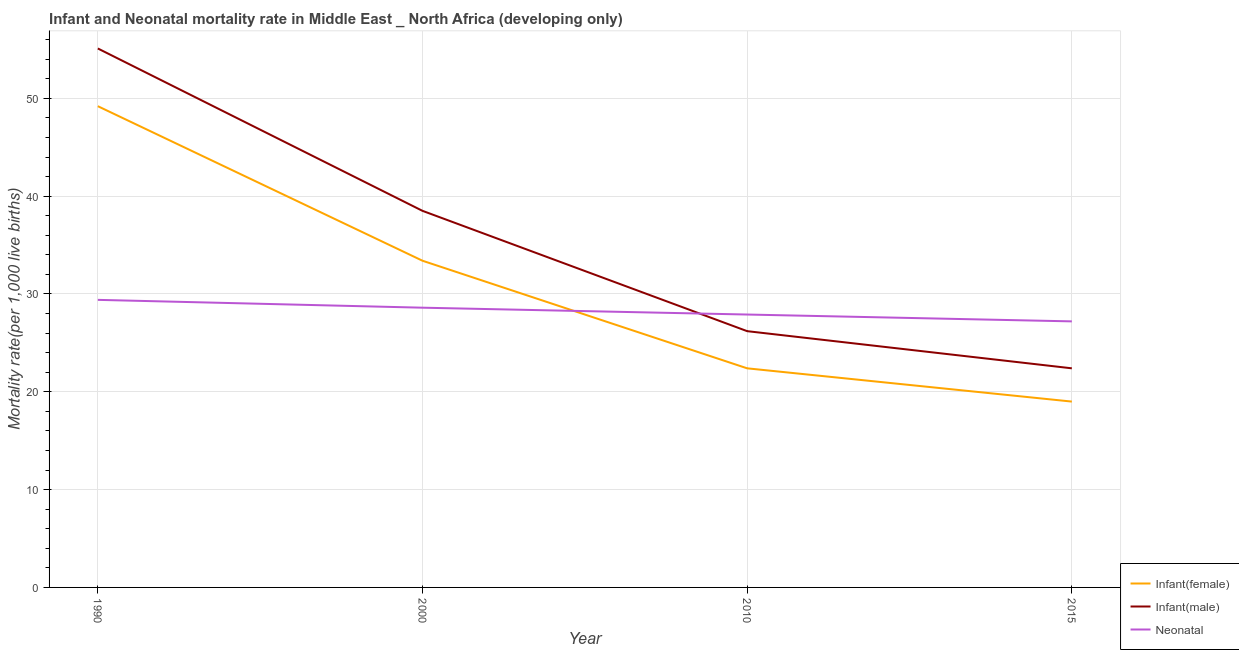Does the line corresponding to neonatal mortality rate intersect with the line corresponding to infant mortality rate(female)?
Give a very brief answer. Yes. What is the infant mortality rate(female) in 1990?
Offer a very short reply. 49.2. Across all years, what is the maximum infant mortality rate(female)?
Give a very brief answer. 49.2. Across all years, what is the minimum infant mortality rate(male)?
Your answer should be very brief. 22.4. In which year was the infant mortality rate(female) minimum?
Your answer should be compact. 2015. What is the total neonatal mortality rate in the graph?
Provide a succinct answer. 113.1. What is the difference between the neonatal mortality rate in 2010 and that in 2015?
Ensure brevity in your answer.  0.7. What is the difference between the infant mortality rate(female) in 2015 and the neonatal mortality rate in 2000?
Make the answer very short. -9.6. What is the average infant mortality rate(female) per year?
Offer a very short reply. 31. In the year 2010, what is the difference between the infant mortality rate(male) and infant mortality rate(female)?
Keep it short and to the point. 3.8. In how many years, is the infant mortality rate(male) greater than 38?
Provide a succinct answer. 2. What is the ratio of the infant mortality rate(female) in 1990 to that in 2010?
Offer a terse response. 2.2. Is the infant mortality rate(female) in 2000 less than that in 2015?
Your response must be concise. No. Is the difference between the infant mortality rate(male) in 2000 and 2015 greater than the difference between the neonatal mortality rate in 2000 and 2015?
Keep it short and to the point. Yes. What is the difference between the highest and the second highest neonatal mortality rate?
Your answer should be very brief. 0.8. What is the difference between the highest and the lowest infant mortality rate(male)?
Offer a terse response. 32.7. Is the sum of the infant mortality rate(female) in 1990 and 2015 greater than the maximum neonatal mortality rate across all years?
Your answer should be very brief. Yes. Is the infant mortality rate(female) strictly greater than the neonatal mortality rate over the years?
Your answer should be very brief. No. Is the infant mortality rate(male) strictly less than the neonatal mortality rate over the years?
Offer a terse response. No. How many years are there in the graph?
Give a very brief answer. 4. Are the values on the major ticks of Y-axis written in scientific E-notation?
Ensure brevity in your answer.  No. Does the graph contain any zero values?
Offer a very short reply. No. Does the graph contain grids?
Your response must be concise. Yes. How many legend labels are there?
Keep it short and to the point. 3. How are the legend labels stacked?
Keep it short and to the point. Vertical. What is the title of the graph?
Offer a terse response. Infant and Neonatal mortality rate in Middle East _ North Africa (developing only). What is the label or title of the Y-axis?
Offer a very short reply. Mortality rate(per 1,0 live births). What is the Mortality rate(per 1,000 live births) of Infant(female) in 1990?
Offer a terse response. 49.2. What is the Mortality rate(per 1,000 live births) in Infant(male) in 1990?
Give a very brief answer. 55.1. What is the Mortality rate(per 1,000 live births) of Neonatal  in 1990?
Provide a succinct answer. 29.4. What is the Mortality rate(per 1,000 live births) of Infant(female) in 2000?
Provide a succinct answer. 33.4. What is the Mortality rate(per 1,000 live births) of Infant(male) in 2000?
Your answer should be very brief. 38.5. What is the Mortality rate(per 1,000 live births) of Neonatal  in 2000?
Your answer should be very brief. 28.6. What is the Mortality rate(per 1,000 live births) of Infant(female) in 2010?
Provide a succinct answer. 22.4. What is the Mortality rate(per 1,000 live births) of Infant(male) in 2010?
Your answer should be very brief. 26.2. What is the Mortality rate(per 1,000 live births) in Neonatal  in 2010?
Keep it short and to the point. 27.9. What is the Mortality rate(per 1,000 live births) in Infant(male) in 2015?
Your answer should be very brief. 22.4. What is the Mortality rate(per 1,000 live births) of Neonatal  in 2015?
Provide a succinct answer. 27.2. Across all years, what is the maximum Mortality rate(per 1,000 live births) of Infant(female)?
Provide a short and direct response. 49.2. Across all years, what is the maximum Mortality rate(per 1,000 live births) of Infant(male)?
Your answer should be very brief. 55.1. Across all years, what is the maximum Mortality rate(per 1,000 live births) in Neonatal ?
Your answer should be compact. 29.4. Across all years, what is the minimum Mortality rate(per 1,000 live births) in Infant(female)?
Provide a short and direct response. 19. Across all years, what is the minimum Mortality rate(per 1,000 live births) of Infant(male)?
Ensure brevity in your answer.  22.4. Across all years, what is the minimum Mortality rate(per 1,000 live births) of Neonatal ?
Provide a short and direct response. 27.2. What is the total Mortality rate(per 1,000 live births) of Infant(female) in the graph?
Offer a terse response. 124. What is the total Mortality rate(per 1,000 live births) in Infant(male) in the graph?
Keep it short and to the point. 142.2. What is the total Mortality rate(per 1,000 live births) in Neonatal  in the graph?
Keep it short and to the point. 113.1. What is the difference between the Mortality rate(per 1,000 live births) in Infant(female) in 1990 and that in 2000?
Give a very brief answer. 15.8. What is the difference between the Mortality rate(per 1,000 live births) of Infant(female) in 1990 and that in 2010?
Give a very brief answer. 26.8. What is the difference between the Mortality rate(per 1,000 live births) in Infant(male) in 1990 and that in 2010?
Provide a short and direct response. 28.9. What is the difference between the Mortality rate(per 1,000 live births) in Neonatal  in 1990 and that in 2010?
Ensure brevity in your answer.  1.5. What is the difference between the Mortality rate(per 1,000 live births) in Infant(female) in 1990 and that in 2015?
Your answer should be compact. 30.2. What is the difference between the Mortality rate(per 1,000 live births) of Infant(male) in 1990 and that in 2015?
Offer a very short reply. 32.7. What is the difference between the Mortality rate(per 1,000 live births) of Infant(female) in 2000 and that in 2010?
Offer a very short reply. 11. What is the difference between the Mortality rate(per 1,000 live births) in Infant(male) in 2000 and that in 2010?
Provide a short and direct response. 12.3. What is the difference between the Mortality rate(per 1,000 live births) of Neonatal  in 2000 and that in 2010?
Offer a terse response. 0.7. What is the difference between the Mortality rate(per 1,000 live births) in Infant(female) in 2000 and that in 2015?
Provide a succinct answer. 14.4. What is the difference between the Mortality rate(per 1,000 live births) in Infant(female) in 2010 and that in 2015?
Provide a succinct answer. 3.4. What is the difference between the Mortality rate(per 1,000 live births) in Infant(male) in 2010 and that in 2015?
Make the answer very short. 3.8. What is the difference between the Mortality rate(per 1,000 live births) in Infant(female) in 1990 and the Mortality rate(per 1,000 live births) in Infant(male) in 2000?
Your answer should be compact. 10.7. What is the difference between the Mortality rate(per 1,000 live births) in Infant(female) in 1990 and the Mortality rate(per 1,000 live births) in Neonatal  in 2000?
Your answer should be compact. 20.6. What is the difference between the Mortality rate(per 1,000 live births) in Infant(female) in 1990 and the Mortality rate(per 1,000 live births) in Infant(male) in 2010?
Provide a succinct answer. 23. What is the difference between the Mortality rate(per 1,000 live births) of Infant(female) in 1990 and the Mortality rate(per 1,000 live births) of Neonatal  in 2010?
Give a very brief answer. 21.3. What is the difference between the Mortality rate(per 1,000 live births) of Infant(male) in 1990 and the Mortality rate(per 1,000 live births) of Neonatal  in 2010?
Keep it short and to the point. 27.2. What is the difference between the Mortality rate(per 1,000 live births) in Infant(female) in 1990 and the Mortality rate(per 1,000 live births) in Infant(male) in 2015?
Offer a terse response. 26.8. What is the difference between the Mortality rate(per 1,000 live births) of Infant(male) in 1990 and the Mortality rate(per 1,000 live births) of Neonatal  in 2015?
Give a very brief answer. 27.9. What is the difference between the Mortality rate(per 1,000 live births) of Infant(female) in 2000 and the Mortality rate(per 1,000 live births) of Infant(male) in 2015?
Your answer should be very brief. 11. What is the difference between the Mortality rate(per 1,000 live births) of Infant(female) in 2000 and the Mortality rate(per 1,000 live births) of Neonatal  in 2015?
Your answer should be compact. 6.2. What is the difference between the Mortality rate(per 1,000 live births) of Infant(female) in 2010 and the Mortality rate(per 1,000 live births) of Neonatal  in 2015?
Provide a succinct answer. -4.8. What is the average Mortality rate(per 1,000 live births) in Infant(female) per year?
Your answer should be compact. 31. What is the average Mortality rate(per 1,000 live births) in Infant(male) per year?
Give a very brief answer. 35.55. What is the average Mortality rate(per 1,000 live births) in Neonatal  per year?
Keep it short and to the point. 28.27. In the year 1990, what is the difference between the Mortality rate(per 1,000 live births) in Infant(female) and Mortality rate(per 1,000 live births) in Infant(male)?
Your answer should be very brief. -5.9. In the year 1990, what is the difference between the Mortality rate(per 1,000 live births) in Infant(female) and Mortality rate(per 1,000 live births) in Neonatal ?
Your response must be concise. 19.8. In the year 1990, what is the difference between the Mortality rate(per 1,000 live births) of Infant(male) and Mortality rate(per 1,000 live births) of Neonatal ?
Your answer should be very brief. 25.7. In the year 2000, what is the difference between the Mortality rate(per 1,000 live births) in Infant(female) and Mortality rate(per 1,000 live births) in Neonatal ?
Provide a short and direct response. 4.8. In the year 2010, what is the difference between the Mortality rate(per 1,000 live births) in Infant(female) and Mortality rate(per 1,000 live births) in Infant(male)?
Provide a succinct answer. -3.8. In the year 2010, what is the difference between the Mortality rate(per 1,000 live births) of Infant(male) and Mortality rate(per 1,000 live births) of Neonatal ?
Your response must be concise. -1.7. In the year 2015, what is the difference between the Mortality rate(per 1,000 live births) in Infant(female) and Mortality rate(per 1,000 live births) in Infant(male)?
Give a very brief answer. -3.4. In the year 2015, what is the difference between the Mortality rate(per 1,000 live births) in Infant(female) and Mortality rate(per 1,000 live births) in Neonatal ?
Your answer should be compact. -8.2. In the year 2015, what is the difference between the Mortality rate(per 1,000 live births) of Infant(male) and Mortality rate(per 1,000 live births) of Neonatal ?
Provide a succinct answer. -4.8. What is the ratio of the Mortality rate(per 1,000 live births) of Infant(female) in 1990 to that in 2000?
Give a very brief answer. 1.47. What is the ratio of the Mortality rate(per 1,000 live births) in Infant(male) in 1990 to that in 2000?
Your answer should be very brief. 1.43. What is the ratio of the Mortality rate(per 1,000 live births) of Neonatal  in 1990 to that in 2000?
Your answer should be compact. 1.03. What is the ratio of the Mortality rate(per 1,000 live births) of Infant(female) in 1990 to that in 2010?
Offer a terse response. 2.2. What is the ratio of the Mortality rate(per 1,000 live births) of Infant(male) in 1990 to that in 2010?
Provide a succinct answer. 2.1. What is the ratio of the Mortality rate(per 1,000 live births) in Neonatal  in 1990 to that in 2010?
Provide a succinct answer. 1.05. What is the ratio of the Mortality rate(per 1,000 live births) in Infant(female) in 1990 to that in 2015?
Provide a succinct answer. 2.59. What is the ratio of the Mortality rate(per 1,000 live births) of Infant(male) in 1990 to that in 2015?
Your answer should be very brief. 2.46. What is the ratio of the Mortality rate(per 1,000 live births) of Neonatal  in 1990 to that in 2015?
Your answer should be very brief. 1.08. What is the ratio of the Mortality rate(per 1,000 live births) of Infant(female) in 2000 to that in 2010?
Give a very brief answer. 1.49. What is the ratio of the Mortality rate(per 1,000 live births) in Infant(male) in 2000 to that in 2010?
Your answer should be compact. 1.47. What is the ratio of the Mortality rate(per 1,000 live births) in Neonatal  in 2000 to that in 2010?
Ensure brevity in your answer.  1.03. What is the ratio of the Mortality rate(per 1,000 live births) of Infant(female) in 2000 to that in 2015?
Offer a terse response. 1.76. What is the ratio of the Mortality rate(per 1,000 live births) of Infant(male) in 2000 to that in 2015?
Provide a succinct answer. 1.72. What is the ratio of the Mortality rate(per 1,000 live births) in Neonatal  in 2000 to that in 2015?
Provide a short and direct response. 1.05. What is the ratio of the Mortality rate(per 1,000 live births) in Infant(female) in 2010 to that in 2015?
Offer a terse response. 1.18. What is the ratio of the Mortality rate(per 1,000 live births) of Infant(male) in 2010 to that in 2015?
Provide a short and direct response. 1.17. What is the ratio of the Mortality rate(per 1,000 live births) in Neonatal  in 2010 to that in 2015?
Ensure brevity in your answer.  1.03. What is the difference between the highest and the lowest Mortality rate(per 1,000 live births) in Infant(female)?
Provide a succinct answer. 30.2. What is the difference between the highest and the lowest Mortality rate(per 1,000 live births) of Infant(male)?
Ensure brevity in your answer.  32.7. 